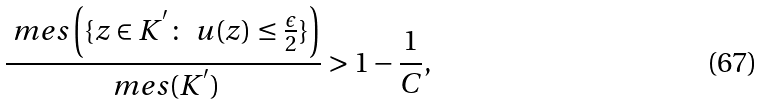Convert formula to latex. <formula><loc_0><loc_0><loc_500><loc_500>\frac { \ m e s \left ( \{ z \in K ^ { ^ { \prime } } \colon \ u ( z ) \leq \frac { \epsilon } { 2 } \} \right ) } { \ m e s ( K ^ { ^ { \prime } } ) } > 1 - \frac { 1 } { C } ,</formula> 